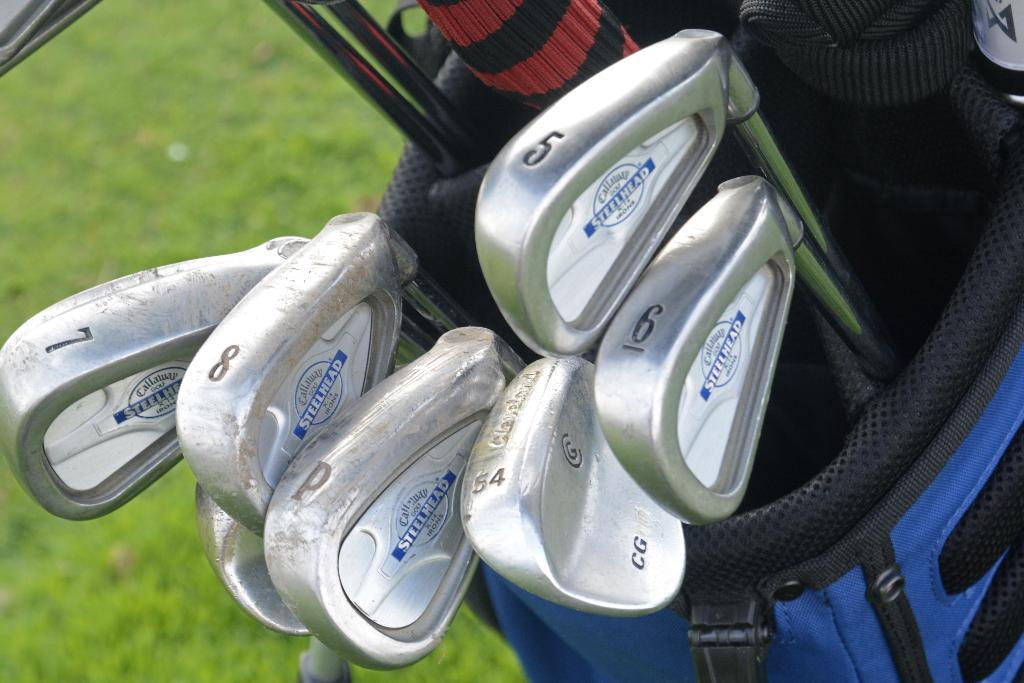What type of sports equipment is present in the image? There are Golf bats in the image. How are the Golf bats being stored or carried? The Golf bats are in a blue color bag. What type of surface is visible at the bottom of the image? There is green color grass visible at the bottom of the image. Can you see any clams on the green grass in the image? There are no clams present in the image; it features Golf bats in a blue color bag and green color grass. What type of flower is growing on the Golf bats in the image? There are no flowers present on the Golf bats in the image; they are stored in a blue color bag. 